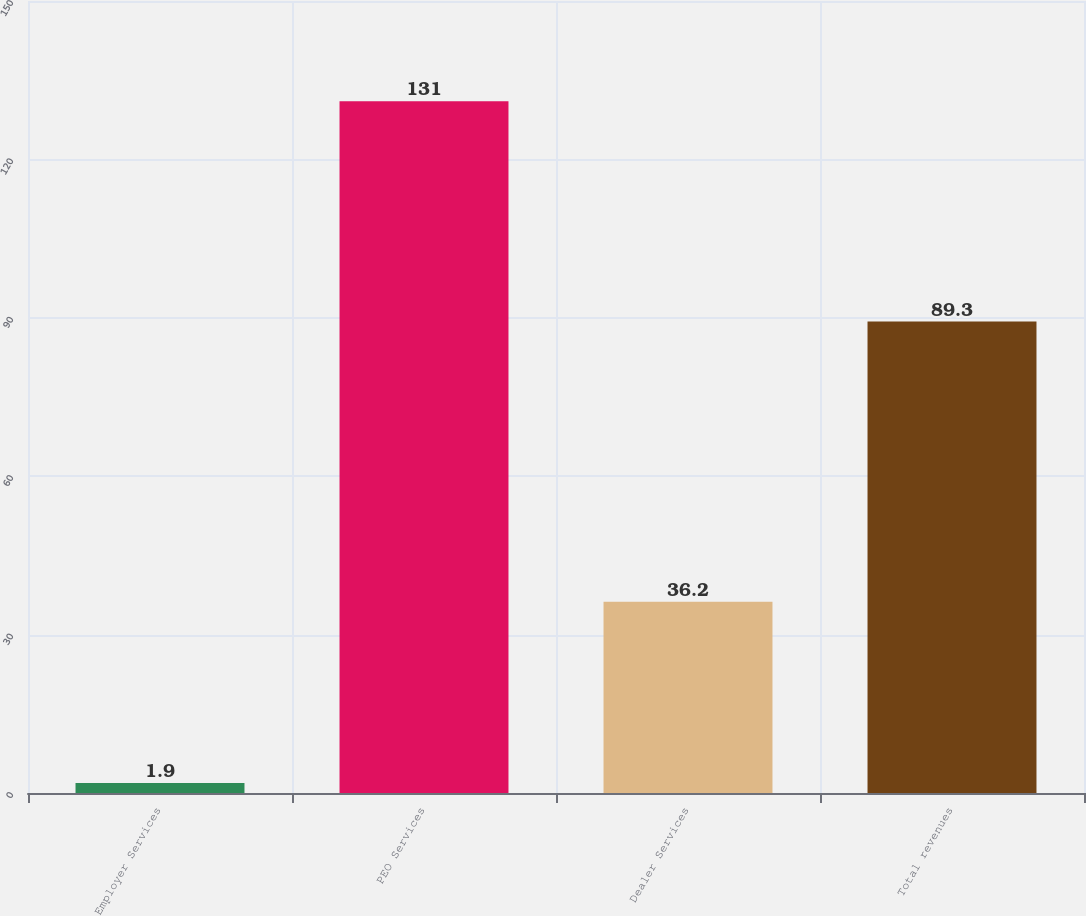<chart> <loc_0><loc_0><loc_500><loc_500><bar_chart><fcel>Employer Services<fcel>PEO Services<fcel>Dealer Services<fcel>Total revenues<nl><fcel>1.9<fcel>131<fcel>36.2<fcel>89.3<nl></chart> 